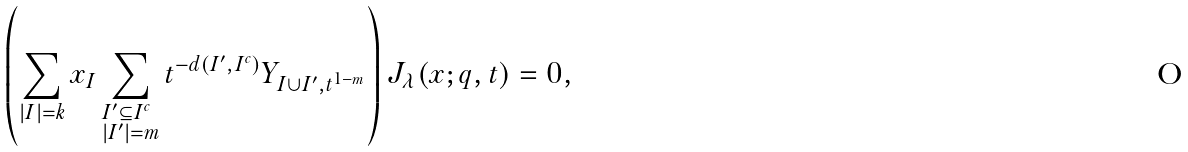<formula> <loc_0><loc_0><loc_500><loc_500>\left ( \sum _ { | I | = k } x _ { I } \sum _ { \begin{subarray} { c } I ^ { \prime } \subseteq I ^ { c } \\ | I ^ { \prime } | = m \end{subarray} } t ^ { - d ( I ^ { \prime } , I ^ { c } ) } Y _ { I \cup I ^ { \prime } , t ^ { 1 - m } } \right ) J _ { \lambda } ( x ; q , t ) = 0 ,</formula> 